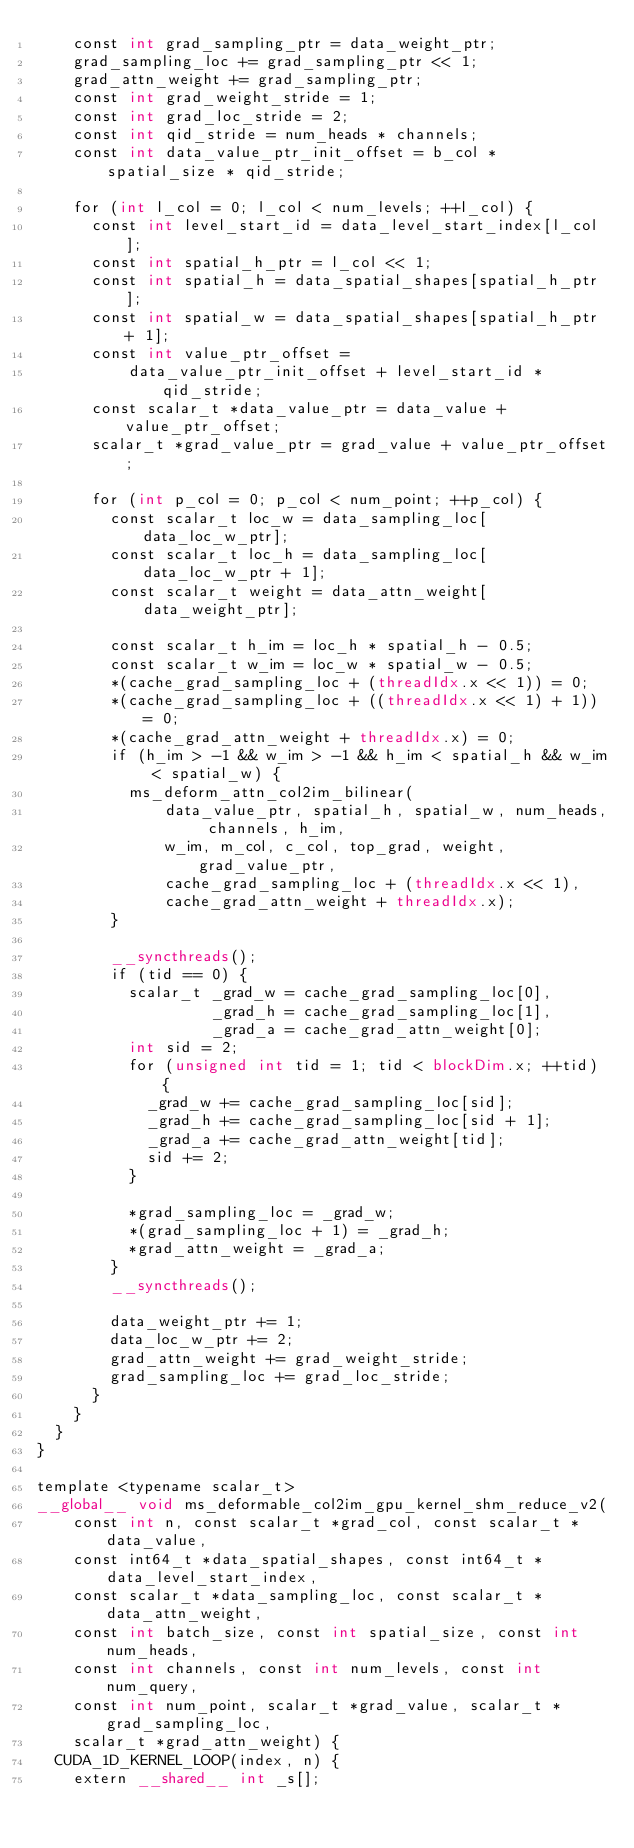<code> <loc_0><loc_0><loc_500><loc_500><_Cuda_>    const int grad_sampling_ptr = data_weight_ptr;
    grad_sampling_loc += grad_sampling_ptr << 1;
    grad_attn_weight += grad_sampling_ptr;
    const int grad_weight_stride = 1;
    const int grad_loc_stride = 2;
    const int qid_stride = num_heads * channels;
    const int data_value_ptr_init_offset = b_col * spatial_size * qid_stride;

    for (int l_col = 0; l_col < num_levels; ++l_col) {
      const int level_start_id = data_level_start_index[l_col];
      const int spatial_h_ptr = l_col << 1;
      const int spatial_h = data_spatial_shapes[spatial_h_ptr];
      const int spatial_w = data_spatial_shapes[spatial_h_ptr + 1];
      const int value_ptr_offset =
          data_value_ptr_init_offset + level_start_id * qid_stride;
      const scalar_t *data_value_ptr = data_value + value_ptr_offset;
      scalar_t *grad_value_ptr = grad_value + value_ptr_offset;

      for (int p_col = 0; p_col < num_point; ++p_col) {
        const scalar_t loc_w = data_sampling_loc[data_loc_w_ptr];
        const scalar_t loc_h = data_sampling_loc[data_loc_w_ptr + 1];
        const scalar_t weight = data_attn_weight[data_weight_ptr];

        const scalar_t h_im = loc_h * spatial_h - 0.5;
        const scalar_t w_im = loc_w * spatial_w - 0.5;
        *(cache_grad_sampling_loc + (threadIdx.x << 1)) = 0;
        *(cache_grad_sampling_loc + ((threadIdx.x << 1) + 1)) = 0;
        *(cache_grad_attn_weight + threadIdx.x) = 0;
        if (h_im > -1 && w_im > -1 && h_im < spatial_h && w_im < spatial_w) {
          ms_deform_attn_col2im_bilinear(
              data_value_ptr, spatial_h, spatial_w, num_heads, channels, h_im,
              w_im, m_col, c_col, top_grad, weight, grad_value_ptr,
              cache_grad_sampling_loc + (threadIdx.x << 1),
              cache_grad_attn_weight + threadIdx.x);
        }

        __syncthreads();
        if (tid == 0) {
          scalar_t _grad_w = cache_grad_sampling_loc[0],
                   _grad_h = cache_grad_sampling_loc[1],
                   _grad_a = cache_grad_attn_weight[0];
          int sid = 2;
          for (unsigned int tid = 1; tid < blockDim.x; ++tid) {
            _grad_w += cache_grad_sampling_loc[sid];
            _grad_h += cache_grad_sampling_loc[sid + 1];
            _grad_a += cache_grad_attn_weight[tid];
            sid += 2;
          }

          *grad_sampling_loc = _grad_w;
          *(grad_sampling_loc + 1) = _grad_h;
          *grad_attn_weight = _grad_a;
        }
        __syncthreads();

        data_weight_ptr += 1;
        data_loc_w_ptr += 2;
        grad_attn_weight += grad_weight_stride;
        grad_sampling_loc += grad_loc_stride;
      }
    }
  }
}

template <typename scalar_t>
__global__ void ms_deformable_col2im_gpu_kernel_shm_reduce_v2(
    const int n, const scalar_t *grad_col, const scalar_t *data_value,
    const int64_t *data_spatial_shapes, const int64_t *data_level_start_index,
    const scalar_t *data_sampling_loc, const scalar_t *data_attn_weight,
    const int batch_size, const int spatial_size, const int num_heads,
    const int channels, const int num_levels, const int num_query,
    const int num_point, scalar_t *grad_value, scalar_t *grad_sampling_loc,
    scalar_t *grad_attn_weight) {
  CUDA_1D_KERNEL_LOOP(index, n) {
    extern __shared__ int _s[];</code> 